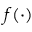Convert formula to latex. <formula><loc_0><loc_0><loc_500><loc_500>f ( \cdot )</formula> 